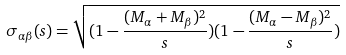<formula> <loc_0><loc_0><loc_500><loc_500>\sigma _ { \alpha \beta } ( s ) = \sqrt { ( 1 - \frac { ( M _ { \alpha } + M _ { \beta } ) ^ { 2 } } { s } ) ( 1 - \frac { ( M _ { \alpha } - M _ { \beta } ) ^ { 2 } } { s } ) }</formula> 